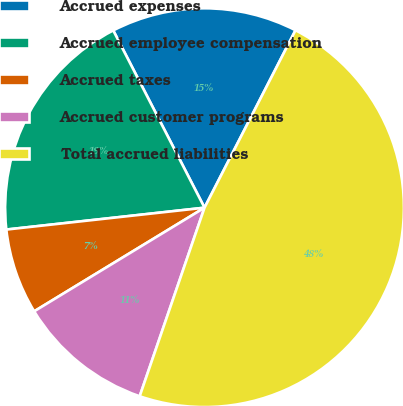<chart> <loc_0><loc_0><loc_500><loc_500><pie_chart><fcel>Accrued expenses<fcel>Accrued employee compensation<fcel>Accrued taxes<fcel>Accrued customer programs<fcel>Total accrued liabilities<nl><fcel>15.11%<fcel>19.18%<fcel>6.95%<fcel>11.03%<fcel>47.73%<nl></chart> 